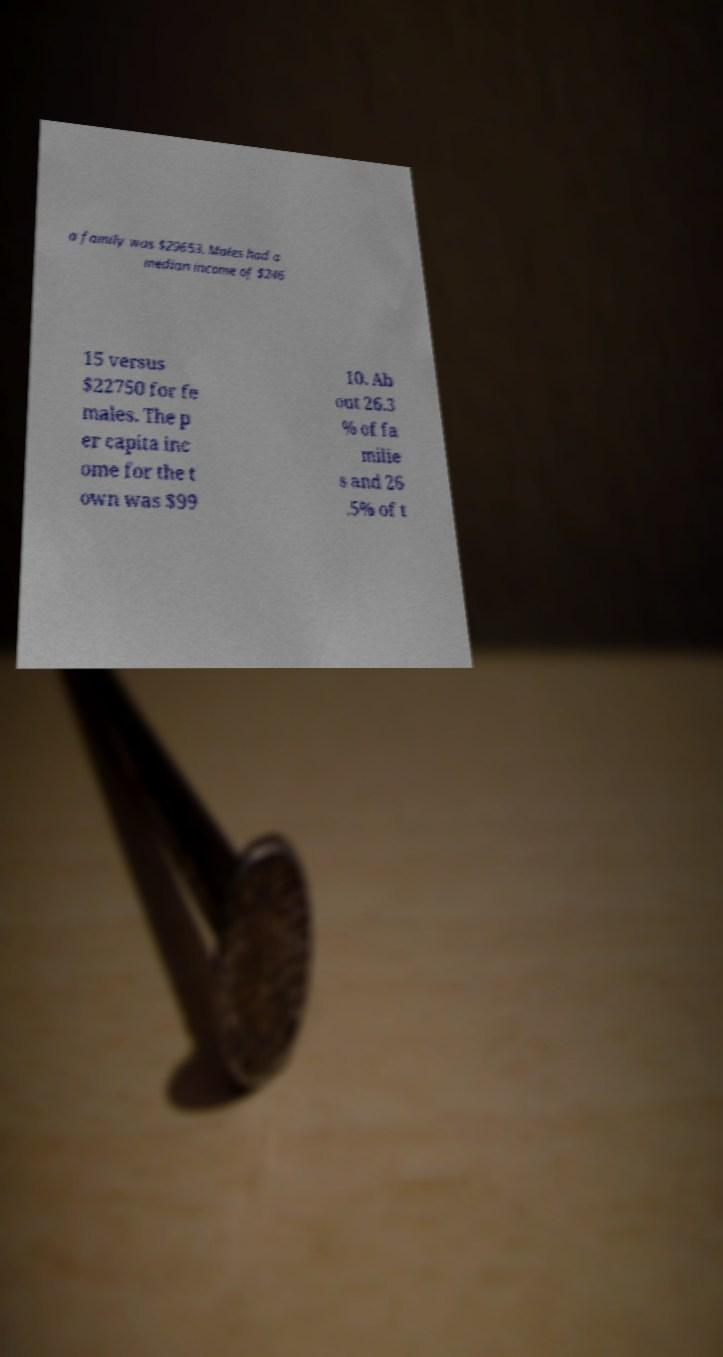Please identify and transcribe the text found in this image. a family was $29653. Males had a median income of $246 15 versus $22750 for fe males. The p er capita inc ome for the t own was $99 10. Ab out 26.3 % of fa milie s and 26 .5% of t 